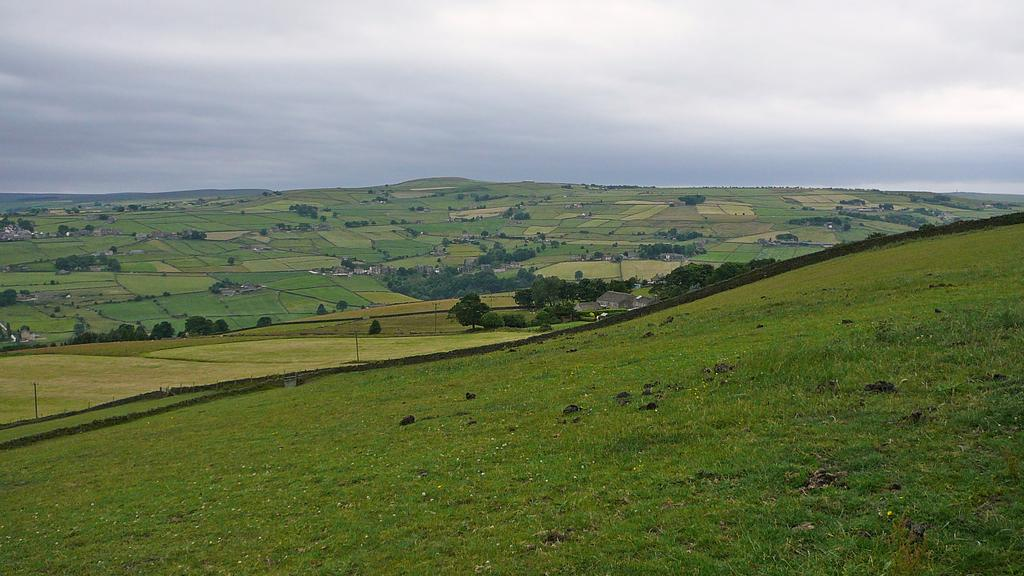What type of landscape is depicted in the image? The image features fields and trees. Are there any elevated features in the image? Yes, there are hills visible in the background of the image. What can be seen in the sky in the image? The sky is visible in the background of the image. How many rats can be seen running through the crowd in the image? There is no crowd or rats present in the image; it features fields, trees, hills, and the sky. 